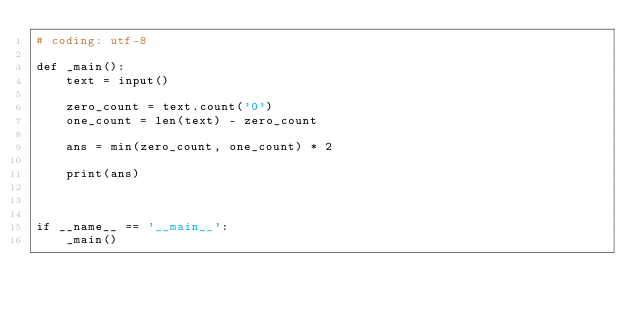<code> <loc_0><loc_0><loc_500><loc_500><_Python_># coding: utf-8

def _main():
    text = input()

    zero_count = text.count('0')
    one_count = len(text) - zero_count

    ans = min(zero_count, one_count) * 2

    print(ans)



if __name__ == '__main__':
    _main()</code> 